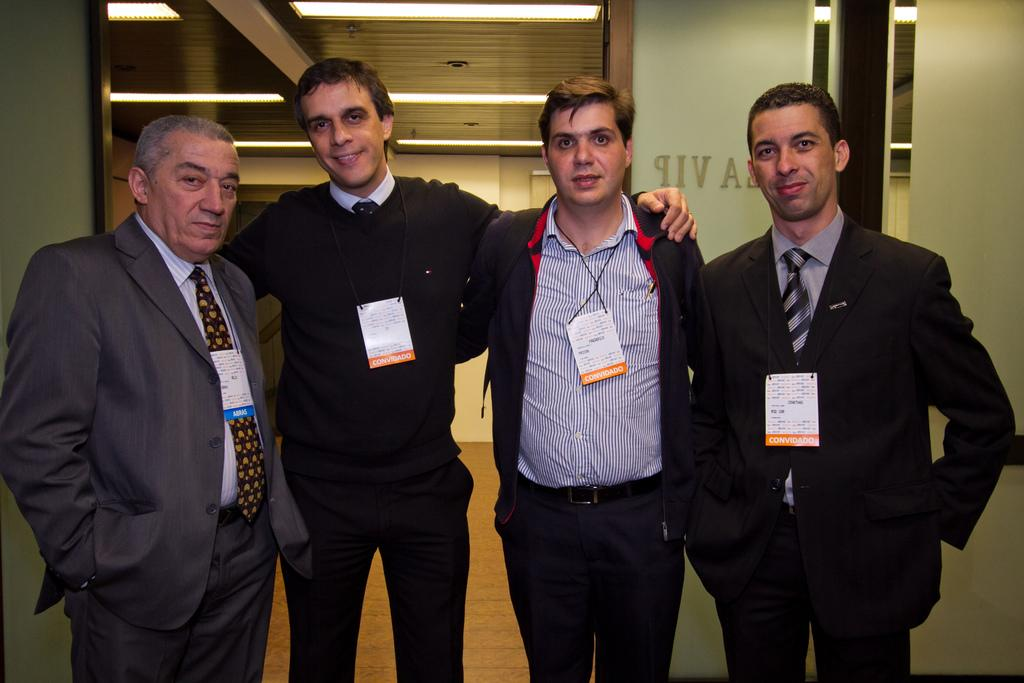How many people are present in the image? There are four people in the image. What are the people doing in the image? The people are standing on the floor and smiling. What can be seen in the background of the image? There is a wall in the background of the image. What is visible at the top of the image? There is a ceiling visible at the top of the image. What type of trade is being discussed by the people in the image? There is no indication in the image that the people are discussing any type of trade. 